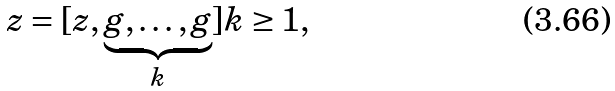Convert formula to latex. <formula><loc_0><loc_0><loc_500><loc_500>z = [ z , \underbrace { g , \dots , g } _ { k } ] k \geq 1 ,</formula> 